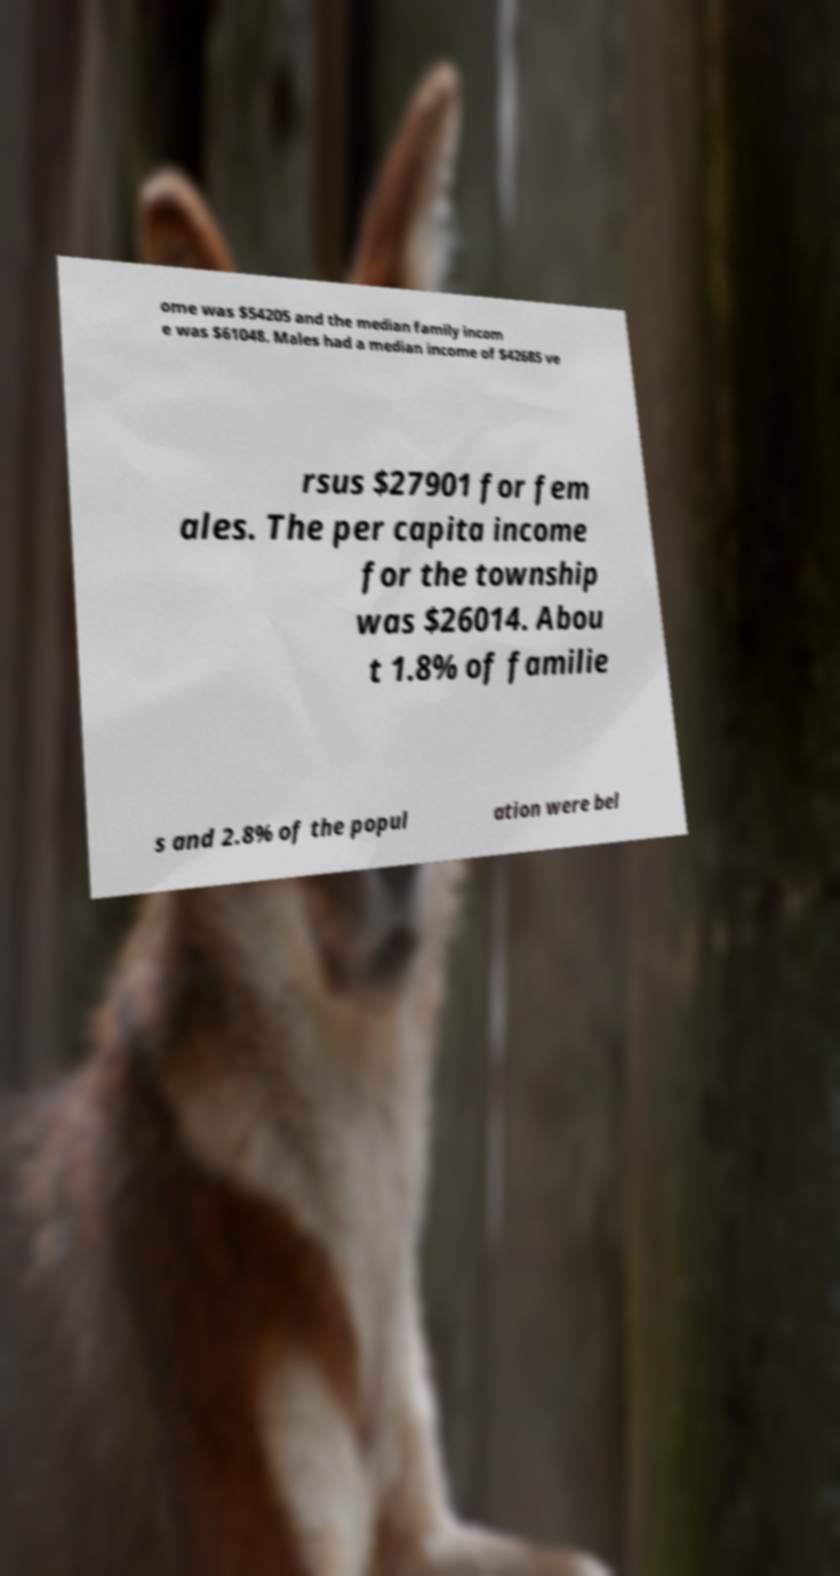What messages or text are displayed in this image? I need them in a readable, typed format. ome was $54205 and the median family incom e was $61048. Males had a median income of $42685 ve rsus $27901 for fem ales. The per capita income for the township was $26014. Abou t 1.8% of familie s and 2.8% of the popul ation were bel 